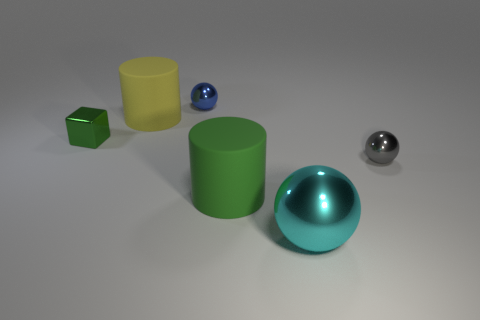Add 2 gray metal spheres. How many objects exist? 8 Subtract all cylinders. How many objects are left? 4 Subtract 0 yellow balls. How many objects are left? 6 Subtract all rubber things. Subtract all cyan shiny things. How many objects are left? 3 Add 5 large matte objects. How many large matte objects are left? 7 Add 2 blue balls. How many blue balls exist? 3 